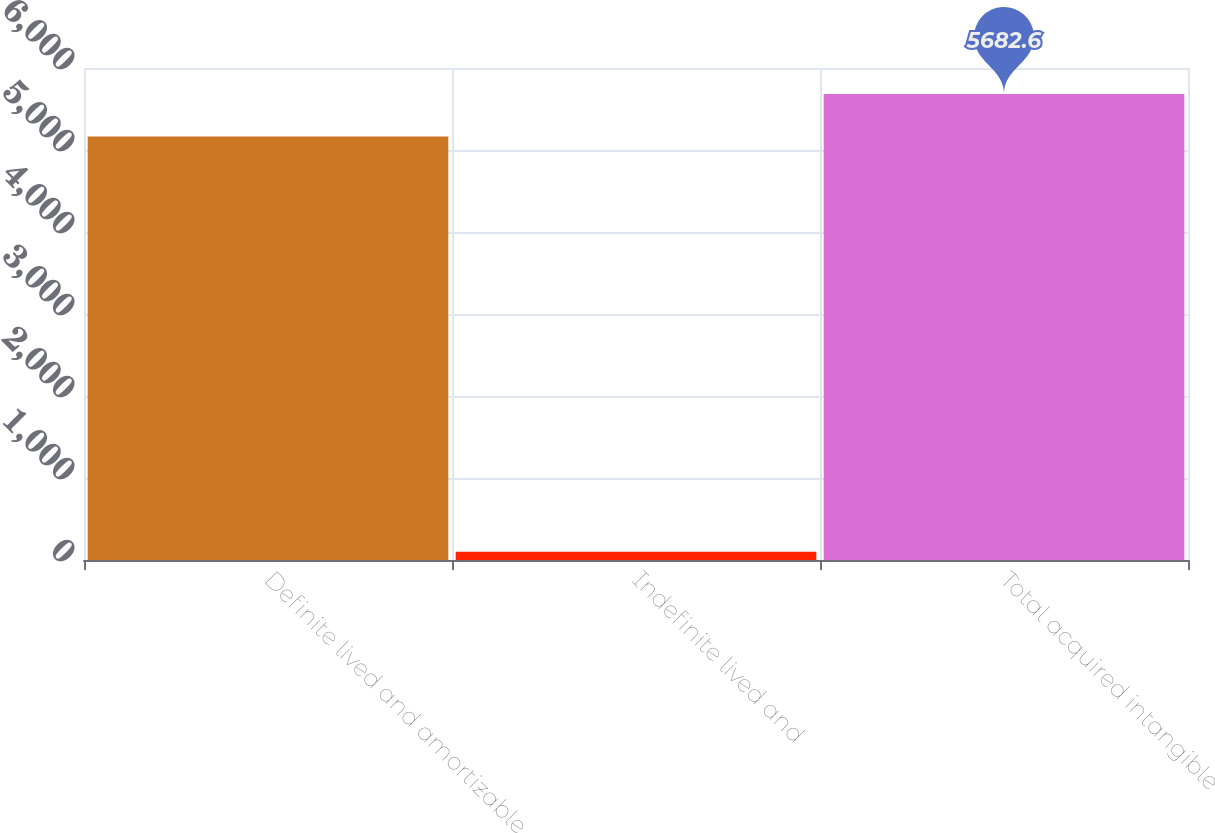<chart> <loc_0><loc_0><loc_500><loc_500><bar_chart><fcel>Definite lived and amortizable<fcel>Indefinite lived and<fcel>Total acquired intangible<nl><fcel>5166<fcel>100<fcel>5682.6<nl></chart> 